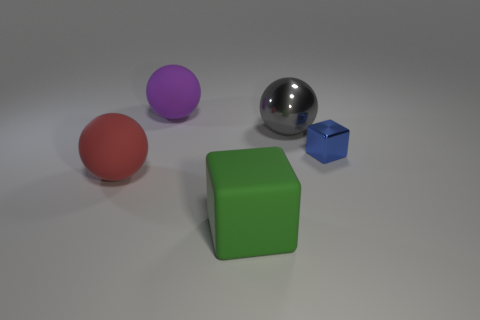Subtract all matte spheres. How many spheres are left? 1 Add 1 small brown metallic spheres. How many objects exist? 6 Subtract all cubes. How many objects are left? 3 Subtract all big green matte cubes. Subtract all green matte blocks. How many objects are left? 3 Add 4 shiny things. How many shiny things are left? 6 Add 2 small metallic things. How many small metallic things exist? 3 Subtract 0 red cylinders. How many objects are left? 5 